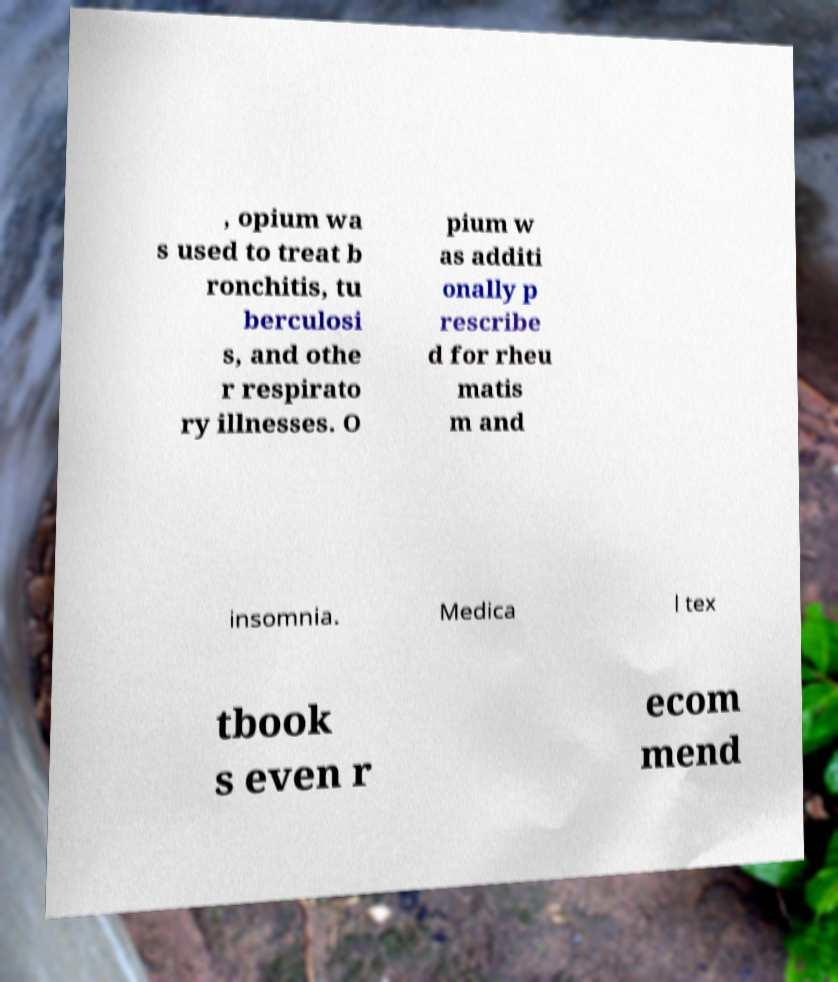I need the written content from this picture converted into text. Can you do that? , opium wa s used to treat b ronchitis, tu berculosi s, and othe r respirato ry illnesses. O pium w as additi onally p rescribe d for rheu matis m and insomnia. Medica l tex tbook s even r ecom mend 